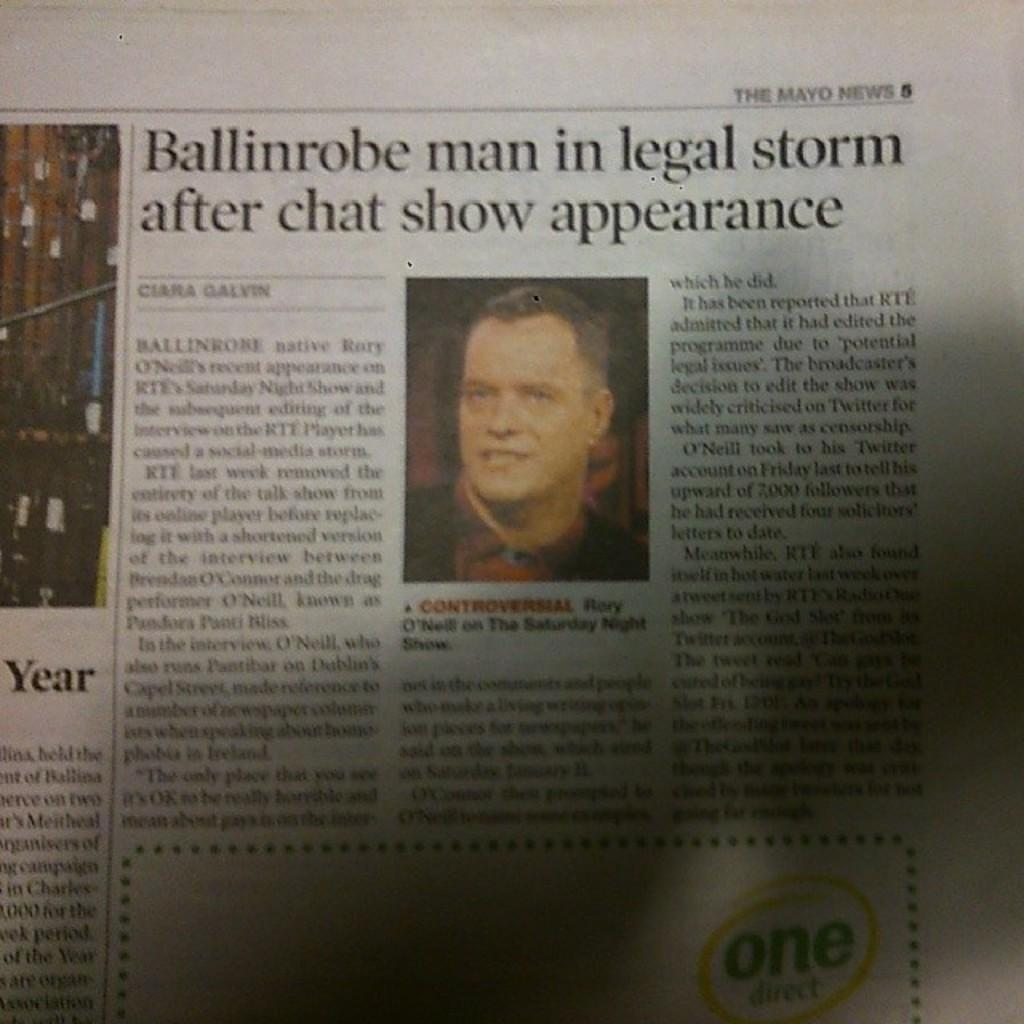What can be seen in the image that is related to news or current events? There is a newspaper in the image. What color is used for the text or headlines in the image? Something is written in black color in the image. Can you identify any human features in the image? There is a person's face visible in the image. What type of cannon is being used to rub the person's face in the image? There is no cannon present in the image, and the person's face is not being rubbed. 